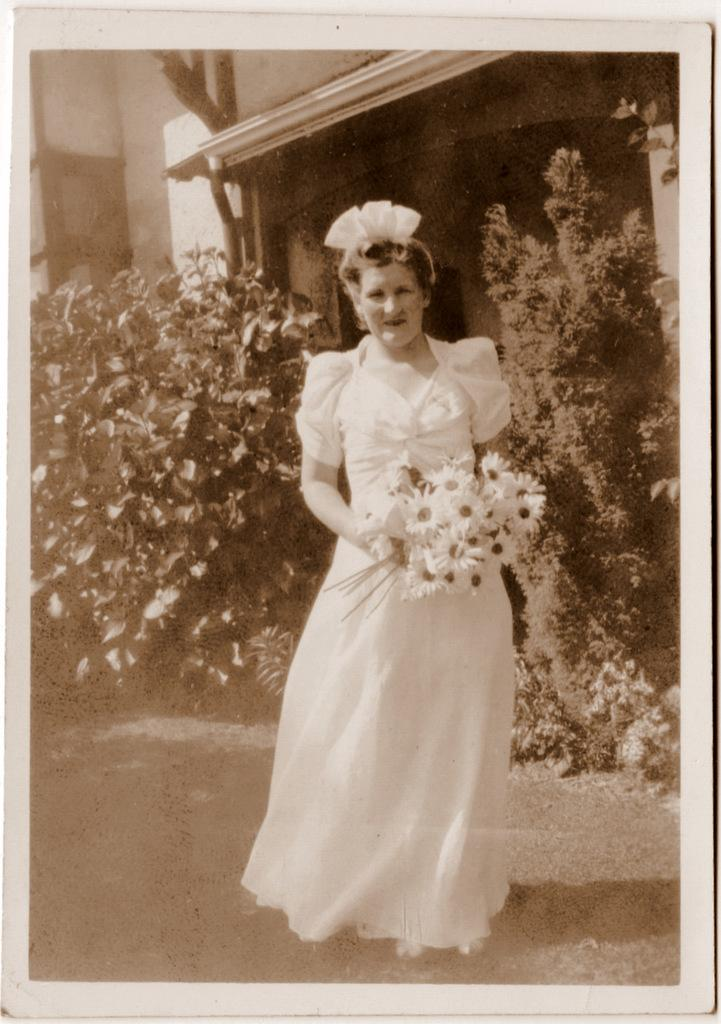Who is the main subject in the image? There is a woman in the image. What is the woman doing in the image? The woman is standing and holding flowers. What can be seen in the background of the image? There is a building in the background of the image. What is located in the middle of the image? There are plants in the middle of the image. What is the color scheme of the image? The image is black and white. What type of butter is being used by the team in the image? There is no butter or team present in the image; it features a woman standing with flowers, surrounded by plants and a building in the background. 